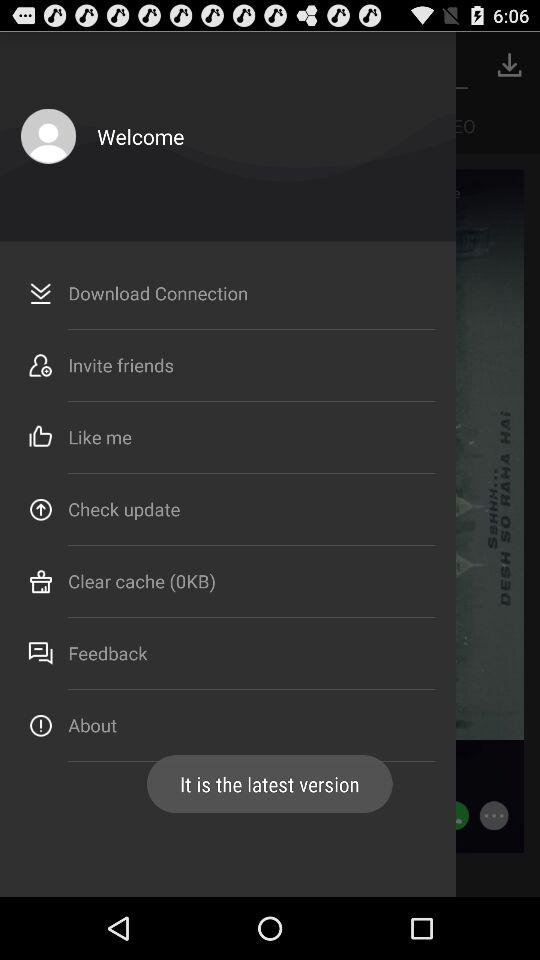What is the size of the clearable cache? The size is 0 KB. 